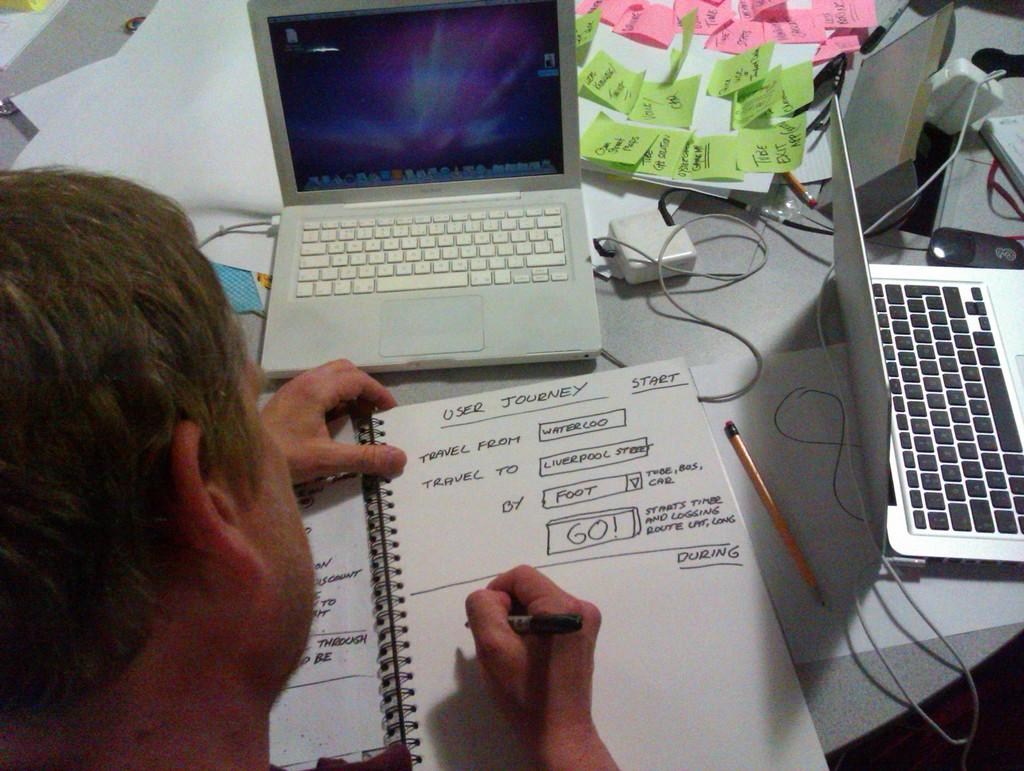<image>
Present a compact description of the photo's key features. a person writing with the word go on it 